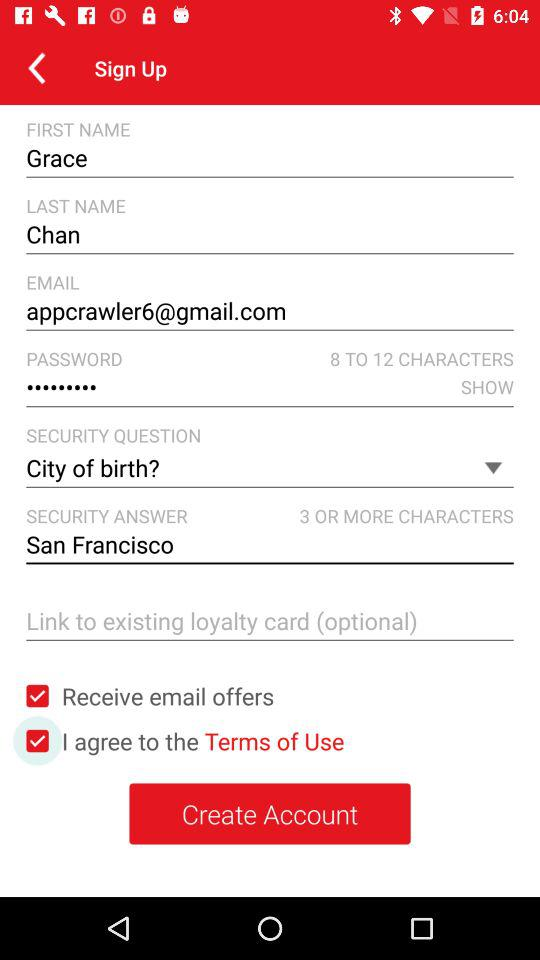What is the last name? The last name is Chan. 